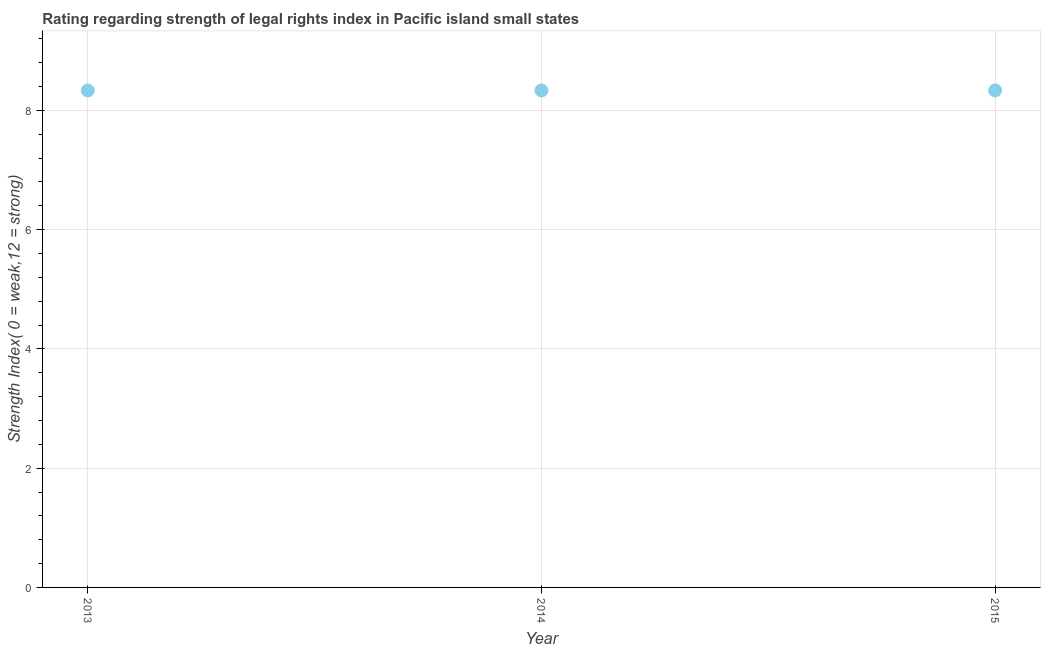What is the strength of legal rights index in 2014?
Your answer should be very brief. 8.33. Across all years, what is the maximum strength of legal rights index?
Offer a terse response. 8.33. Across all years, what is the minimum strength of legal rights index?
Keep it short and to the point. 8.33. In which year was the strength of legal rights index maximum?
Keep it short and to the point. 2013. In which year was the strength of legal rights index minimum?
Keep it short and to the point. 2013. What is the sum of the strength of legal rights index?
Provide a short and direct response. 25. What is the average strength of legal rights index per year?
Provide a succinct answer. 8.33. What is the median strength of legal rights index?
Make the answer very short. 8.33. In how many years, is the strength of legal rights index greater than 5.2 ?
Make the answer very short. 3. Is the strength of legal rights index in 2014 less than that in 2015?
Your answer should be very brief. No. Is the difference between the strength of legal rights index in 2014 and 2015 greater than the difference between any two years?
Offer a terse response. Yes. What is the difference between the highest and the second highest strength of legal rights index?
Offer a terse response. 0. Is the sum of the strength of legal rights index in 2014 and 2015 greater than the maximum strength of legal rights index across all years?
Make the answer very short. Yes. What is the difference between the highest and the lowest strength of legal rights index?
Your response must be concise. 0. In how many years, is the strength of legal rights index greater than the average strength of legal rights index taken over all years?
Ensure brevity in your answer.  0. Does the strength of legal rights index monotonically increase over the years?
Your answer should be very brief. No. How many years are there in the graph?
Give a very brief answer. 3. What is the difference between two consecutive major ticks on the Y-axis?
Your answer should be very brief. 2. Does the graph contain grids?
Give a very brief answer. Yes. What is the title of the graph?
Give a very brief answer. Rating regarding strength of legal rights index in Pacific island small states. What is the label or title of the Y-axis?
Your answer should be very brief. Strength Index( 0 = weak,12 = strong). What is the Strength Index( 0 = weak,12 = strong) in 2013?
Provide a short and direct response. 8.33. What is the Strength Index( 0 = weak,12 = strong) in 2014?
Your response must be concise. 8.33. What is the Strength Index( 0 = weak,12 = strong) in 2015?
Keep it short and to the point. 8.33. What is the difference between the Strength Index( 0 = weak,12 = strong) in 2013 and 2014?
Provide a short and direct response. 0. What is the difference between the Strength Index( 0 = weak,12 = strong) in 2013 and 2015?
Offer a very short reply. 0. What is the difference between the Strength Index( 0 = weak,12 = strong) in 2014 and 2015?
Your answer should be compact. 0. What is the ratio of the Strength Index( 0 = weak,12 = strong) in 2013 to that in 2014?
Ensure brevity in your answer.  1. What is the ratio of the Strength Index( 0 = weak,12 = strong) in 2014 to that in 2015?
Provide a succinct answer. 1. 